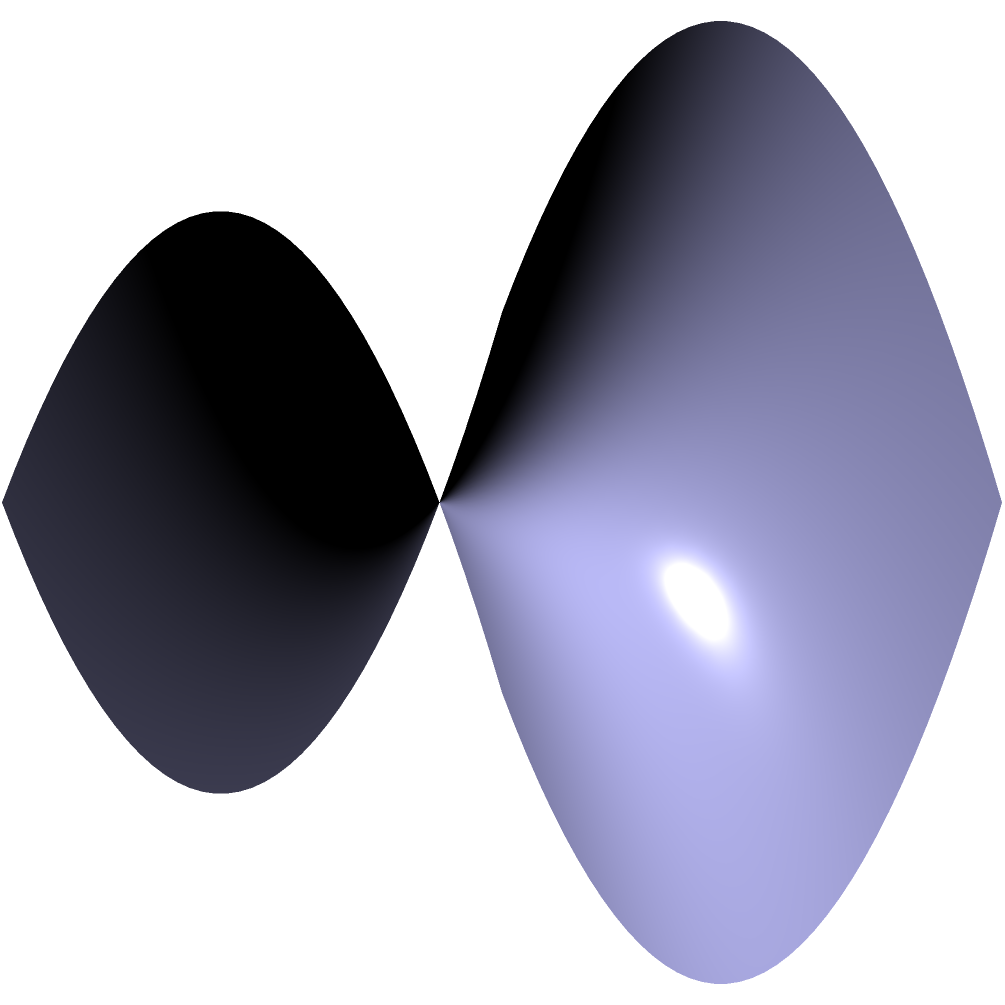In Chester Park, a new playground is being planned on a saddle-shaped terrain. The proposed area is represented by a square with side length 3 units on the surface $z = 0.5(x^2 - y^2)$. What is the approximate surface area of the playground? To find the surface area on a saddle-shaped surface, we need to use the surface integral formula:

$$A = \iint_S \sqrt{1 + (\frac{\partial z}{\partial x})^2 + (\frac{\partial z}{\partial y})^2} \, dA$$

Steps to solve:

1) First, we need to find the partial derivatives:
   $\frac{\partial z}{\partial x} = x$ and $\frac{\partial z}{\partial y} = -y$

2) Substituting into the formula:
   $$A = \iint_S \sqrt{1 + x^2 + y^2} \, dA$$

3) The square has side length 3, so we integrate from -1.5 to 1.5 for both x and y:
   $$A = \int_{-1.5}^{1.5} \int_{-1.5}^{1.5} \sqrt{1 + x^2 + y^2} \, dx \, dy$$

4) This integral is difficult to solve analytically, so we can use numerical integration methods.

5) Using a numerical integration tool, we find that the approximate value of this integral is about 9.67 square units.
Answer: 9.67 square units 